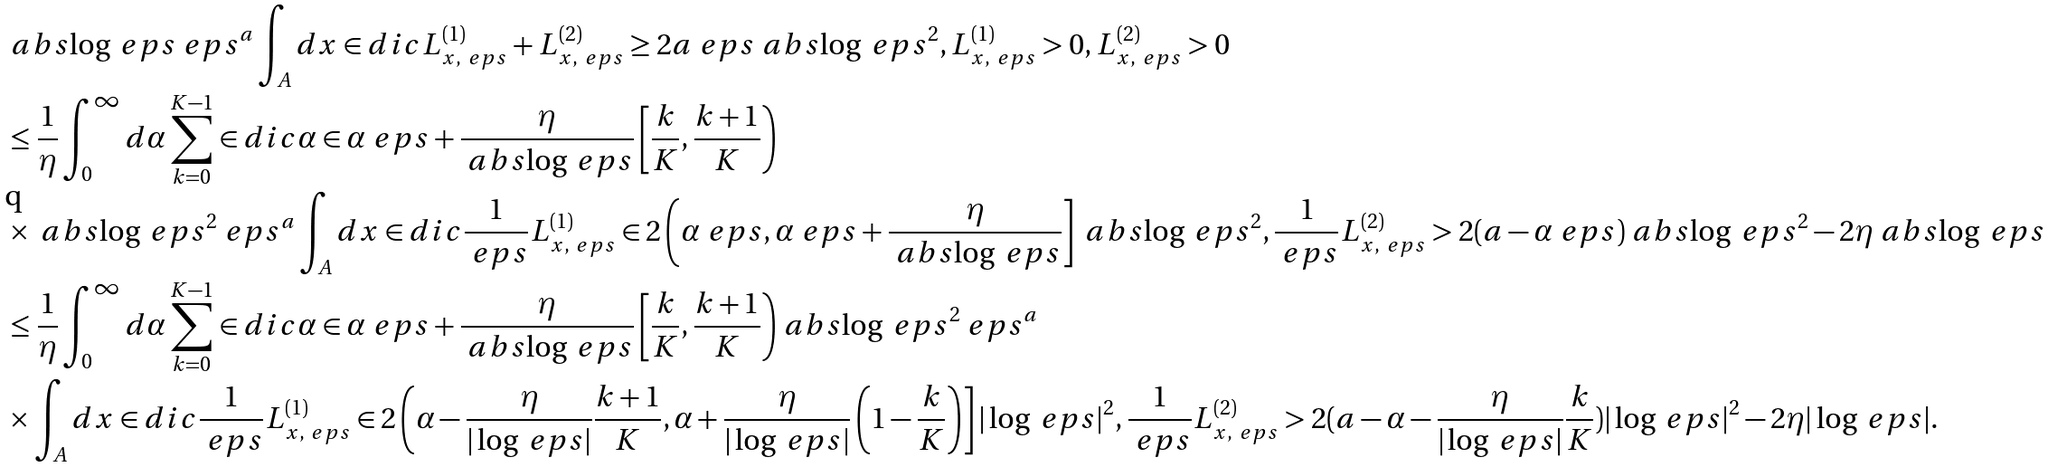Convert formula to latex. <formula><loc_0><loc_0><loc_500><loc_500>& \ a b s { \log \ e p s } \ e p s ^ { a } \int _ { A } d x \in d i c { L _ { x , \ e p s } ^ { ( 1 ) } + L _ { x , \ e p s } ^ { ( 2 ) } \geq 2 a \ e p s \ a b s { \log \ e p s } ^ { 2 } , L _ { x , \ e p s } ^ { ( 1 ) } > 0 , L _ { x , \ e p s } ^ { ( 2 ) } > 0 } \\ & \leq \frac { 1 } { \eta } \int _ { 0 } ^ { \infty } d \alpha \sum _ { k = 0 } ^ { K - 1 } \in d i c { \alpha \in \alpha _ { \ } e p s + \frac { \eta } { \ a b s { \log \ e p s } } \left [ \frac { k } { K } , \frac { k + 1 } { K } \right ) } \\ & \times \ a b s { \log \ e p s } ^ { 2 } \ e p s ^ { a } \int _ { A } d x \in d i c { \frac { 1 } { \ e p s } L _ { x , \ e p s } ^ { ( 1 ) } \in 2 \left ( \alpha _ { \ } e p s , \alpha _ { \ } e p s + \frac { \eta } { \ a b s { \log \ e p s } } \right ] \ a b s { \log \ e p s } ^ { 2 } , \frac { 1 } { \ e p s } L _ { x , \ e p s } ^ { ( 2 ) } > 2 ( a - \alpha _ { \ } e p s ) \ a b s { \log \ e p s } ^ { 2 } - 2 \eta \ a b s { \log \ e p s } } \\ & \leq \frac { 1 } { \eta } \int _ { 0 } ^ { \infty } d \alpha \sum _ { k = 0 } ^ { K - 1 } \in d i c { \alpha \in \alpha _ { \ } e p s + \frac { \eta } { \ a b s { \log \ e p s } } \left [ \frac { k } { K } , \frac { k + 1 } { K } \right ) } \ a b s { \log \ e p s } ^ { 2 } \ e p s ^ { a } \\ & \times \int _ { A } d x \in d i c { \frac { 1 } { \ e p s } L _ { x , \ e p s } ^ { ( 1 ) } \in 2 \left ( \alpha - \frac { \eta } { | \log \ e p s | } \frac { k + 1 } { K } , \alpha + \frac { \eta } { | \log \ e p s | } \left ( 1 - \frac { k } { K } \right ) \right ] | \log \ e p s | ^ { 2 } , \frac { 1 } { \ e p s } L _ { x , \ e p s } ^ { ( 2 ) } > 2 ( a - \alpha - \frac { \eta } { | \log \ e p s | } \frac { k } { K } ) | \log \ e p s | ^ { 2 } - 2 \eta | \log \ e p s | } .</formula> 